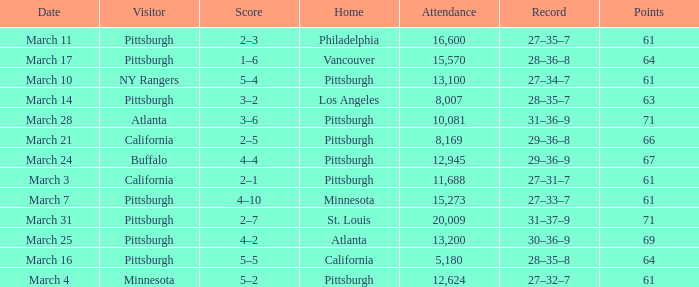What is the Score of the game with a Record of 31–37–9? 2–7. 